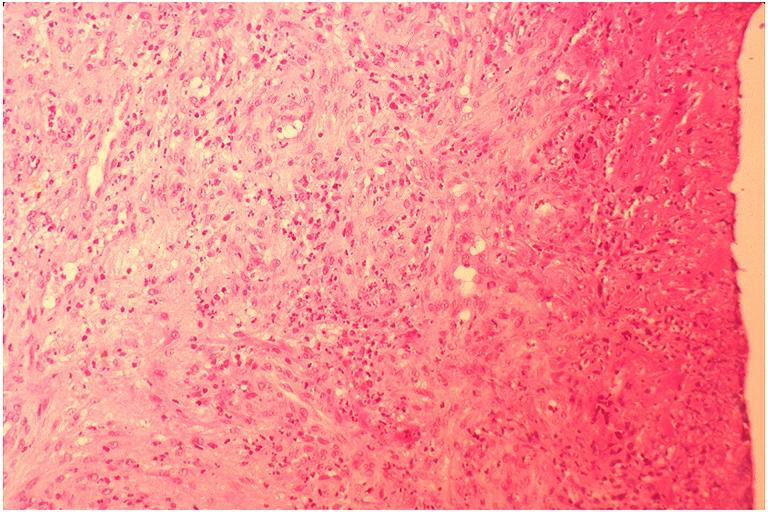does squamous cell carcinoma, lip remote, show pyogenic granuloma?
Answer the question using a single word or phrase. No 